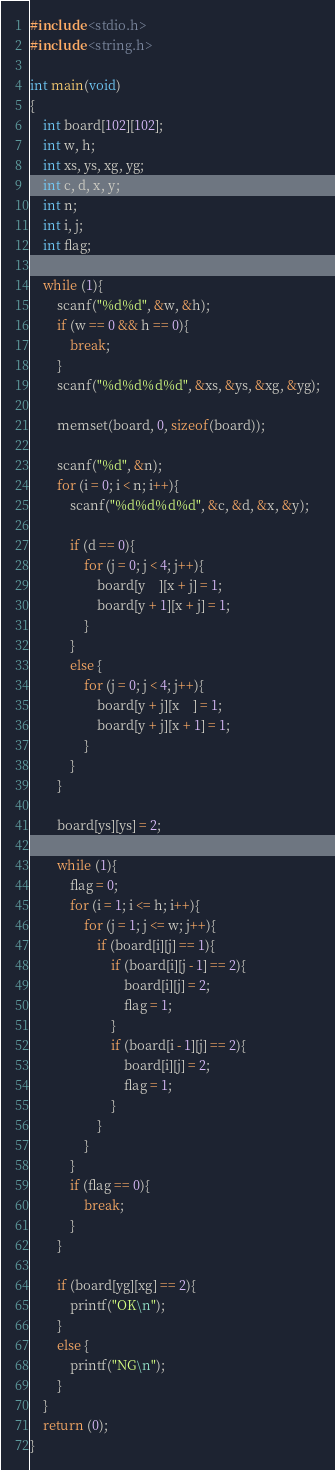Convert code to text. <code><loc_0><loc_0><loc_500><loc_500><_C_>#include <stdio.h>
#include <string.h>

int main(void)
{
    int board[102][102];
    int w, h;
    int xs, ys, xg, yg;
    int c, d, x, y;
    int n;
    int i, j;
    int flag;
    
    while (1){
        scanf("%d%d", &w, &h);
        if (w == 0 && h == 0){
            break;
        }
        scanf("%d%d%d%d", &xs, &ys, &xg, &yg);

        memset(board, 0, sizeof(board));

        scanf("%d", &n);
        for (i = 0; i < n; i++){
            scanf("%d%d%d%d", &c, &d, &x, &y);
            
            if (d == 0){
                for (j = 0; j < 4; j++){
                    board[y    ][x + j] = 1;
                    board[y + 1][x + j] = 1;
                }
            }
            else {
                for (j = 0; j < 4; j++){
                    board[y + j][x    ] = 1;
                    board[y + j][x + 1] = 1;
                }
            }
        }
        
        board[ys][ys] = 2;
        
        while (1){
            flag = 0;
            for (i = 1; i <= h; i++){
                for (j = 1; j <= w; j++){
                    if (board[i][j] == 1){
                        if (board[i][j - 1] == 2){
                            board[i][j] = 2;
                            flag = 1;
                        }
                        if (board[i - 1][j] == 2){
                            board[i][j] = 2;
                            flag = 1;
                        }
                    }
                }
            }
            if (flag == 0){
                break;
            }
        }
        
        if (board[yg][xg] == 2){
            printf("OK\n");
        }
        else {
            printf("NG\n");
        }
    }
    return (0);
}</code> 